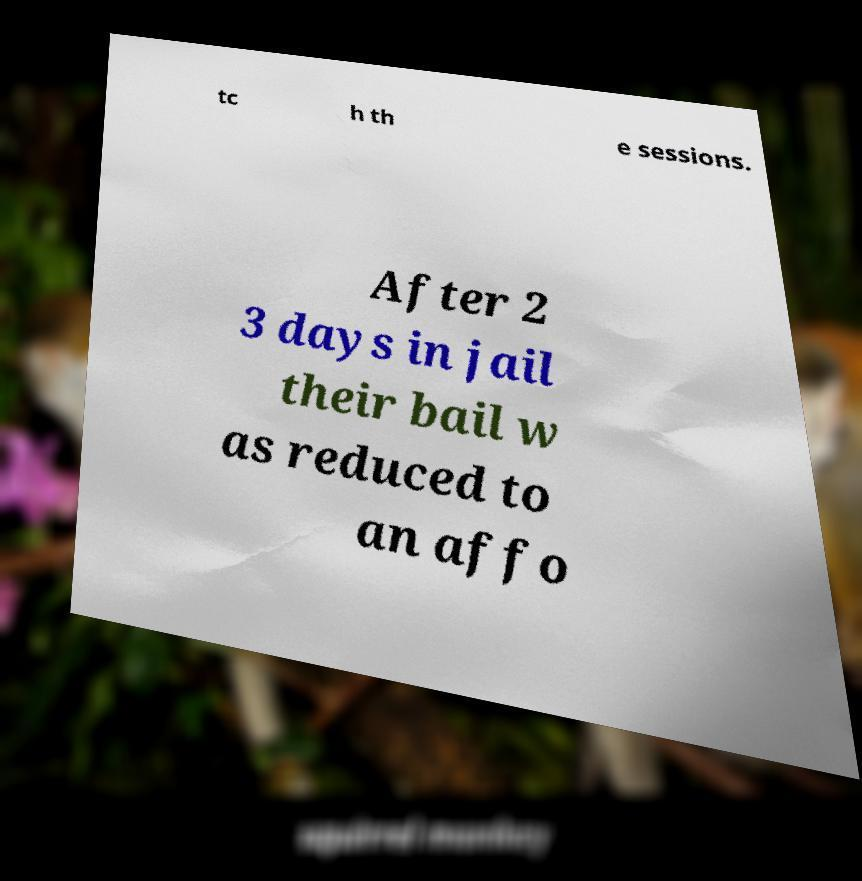Can you read and provide the text displayed in the image?This photo seems to have some interesting text. Can you extract and type it out for me? tc h th e sessions. After 2 3 days in jail their bail w as reduced to an affo 